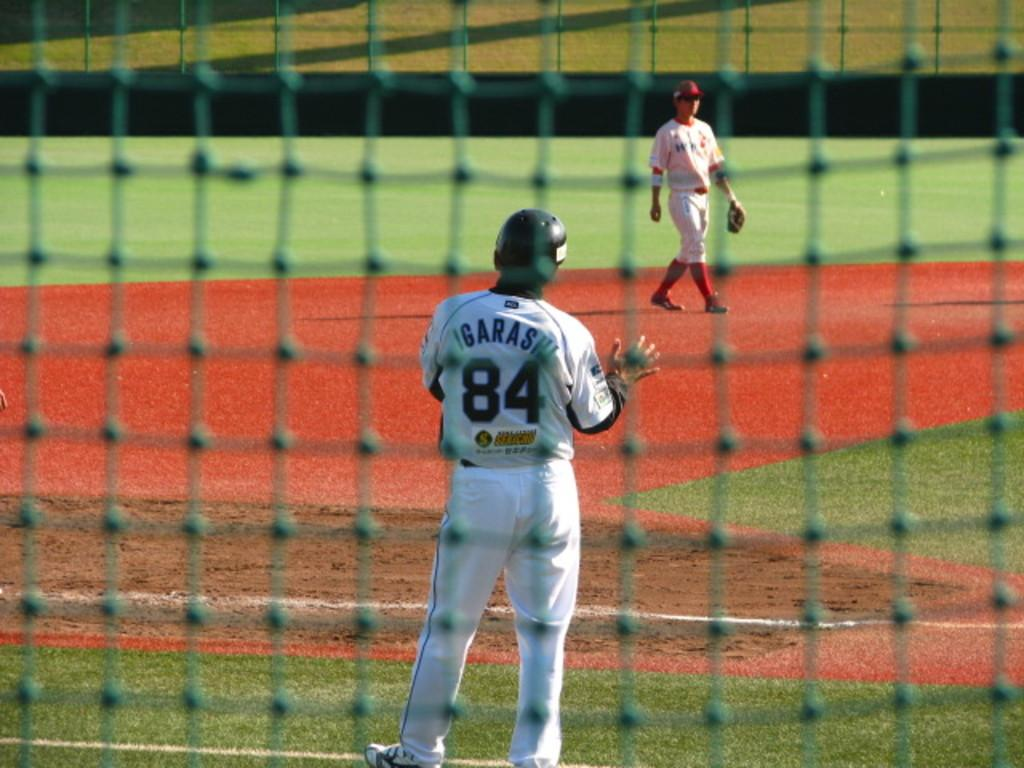<image>
Share a concise interpretation of the image provided. A baseball player is in the field while Igarashi number 84 stands with a helmet on. 